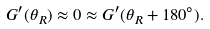Convert formula to latex. <formula><loc_0><loc_0><loc_500><loc_500>G ^ { \prime } ( \theta _ { R } ) \approx 0 \approx G ^ { \prime } ( \theta _ { R } + 1 8 0 ^ { \circ } ) .</formula> 